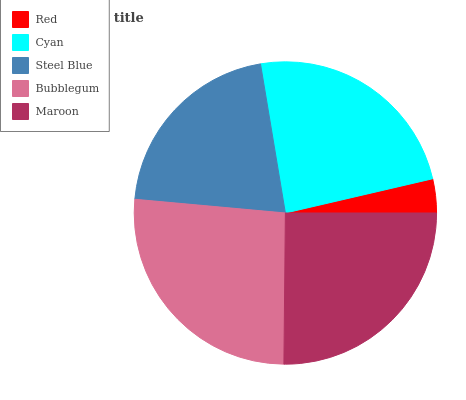Is Red the minimum?
Answer yes or no. Yes. Is Bubblegum the maximum?
Answer yes or no. Yes. Is Cyan the minimum?
Answer yes or no. No. Is Cyan the maximum?
Answer yes or no. No. Is Cyan greater than Red?
Answer yes or no. Yes. Is Red less than Cyan?
Answer yes or no. Yes. Is Red greater than Cyan?
Answer yes or no. No. Is Cyan less than Red?
Answer yes or no. No. Is Cyan the high median?
Answer yes or no. Yes. Is Cyan the low median?
Answer yes or no. Yes. Is Bubblegum the high median?
Answer yes or no. No. Is Maroon the low median?
Answer yes or no. No. 